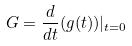<formula> <loc_0><loc_0><loc_500><loc_500>G = \frac { d } { d t } ( g ( t ) ) | _ { t = 0 }</formula> 